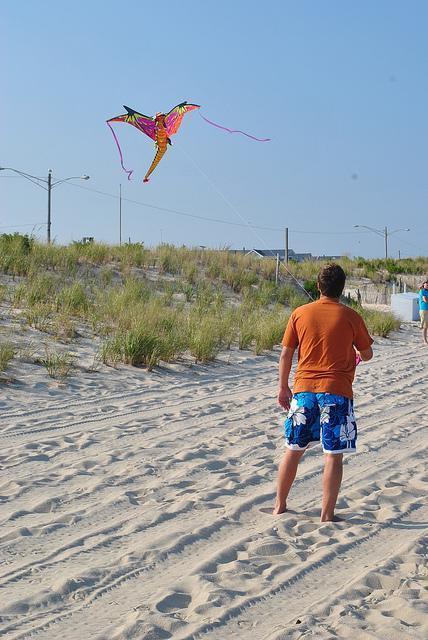How many balls in picture?
Give a very brief answer. 0. How many people are there?
Give a very brief answer. 1. How many light blue umbrellas are in the image?
Give a very brief answer. 0. 